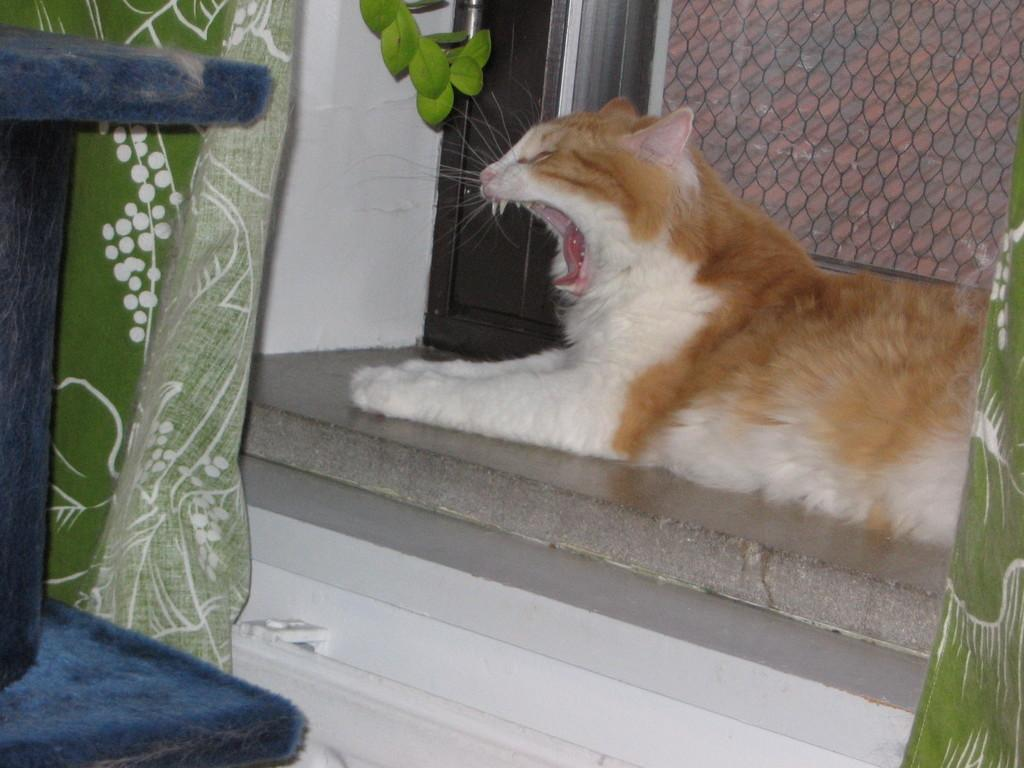What is the main subject in the center of the image? There is a cat in the center of the image. What can be seen in the background of the image? There is a door and a net in the background of the image. What objects are on the left side of the image? There is a blanket and a chair on the left side of the image. What is visible at the bottom of the image? There is a floor visible at the bottom of the image. What type of goat can be seen interacting with the cat in the image? There is no goat present in the image; it only features a cat, a door, a net, a blanket, a chair, and a floor. Who is the creator of the cat in the image? The image does not provide information about the creator of the cat. 